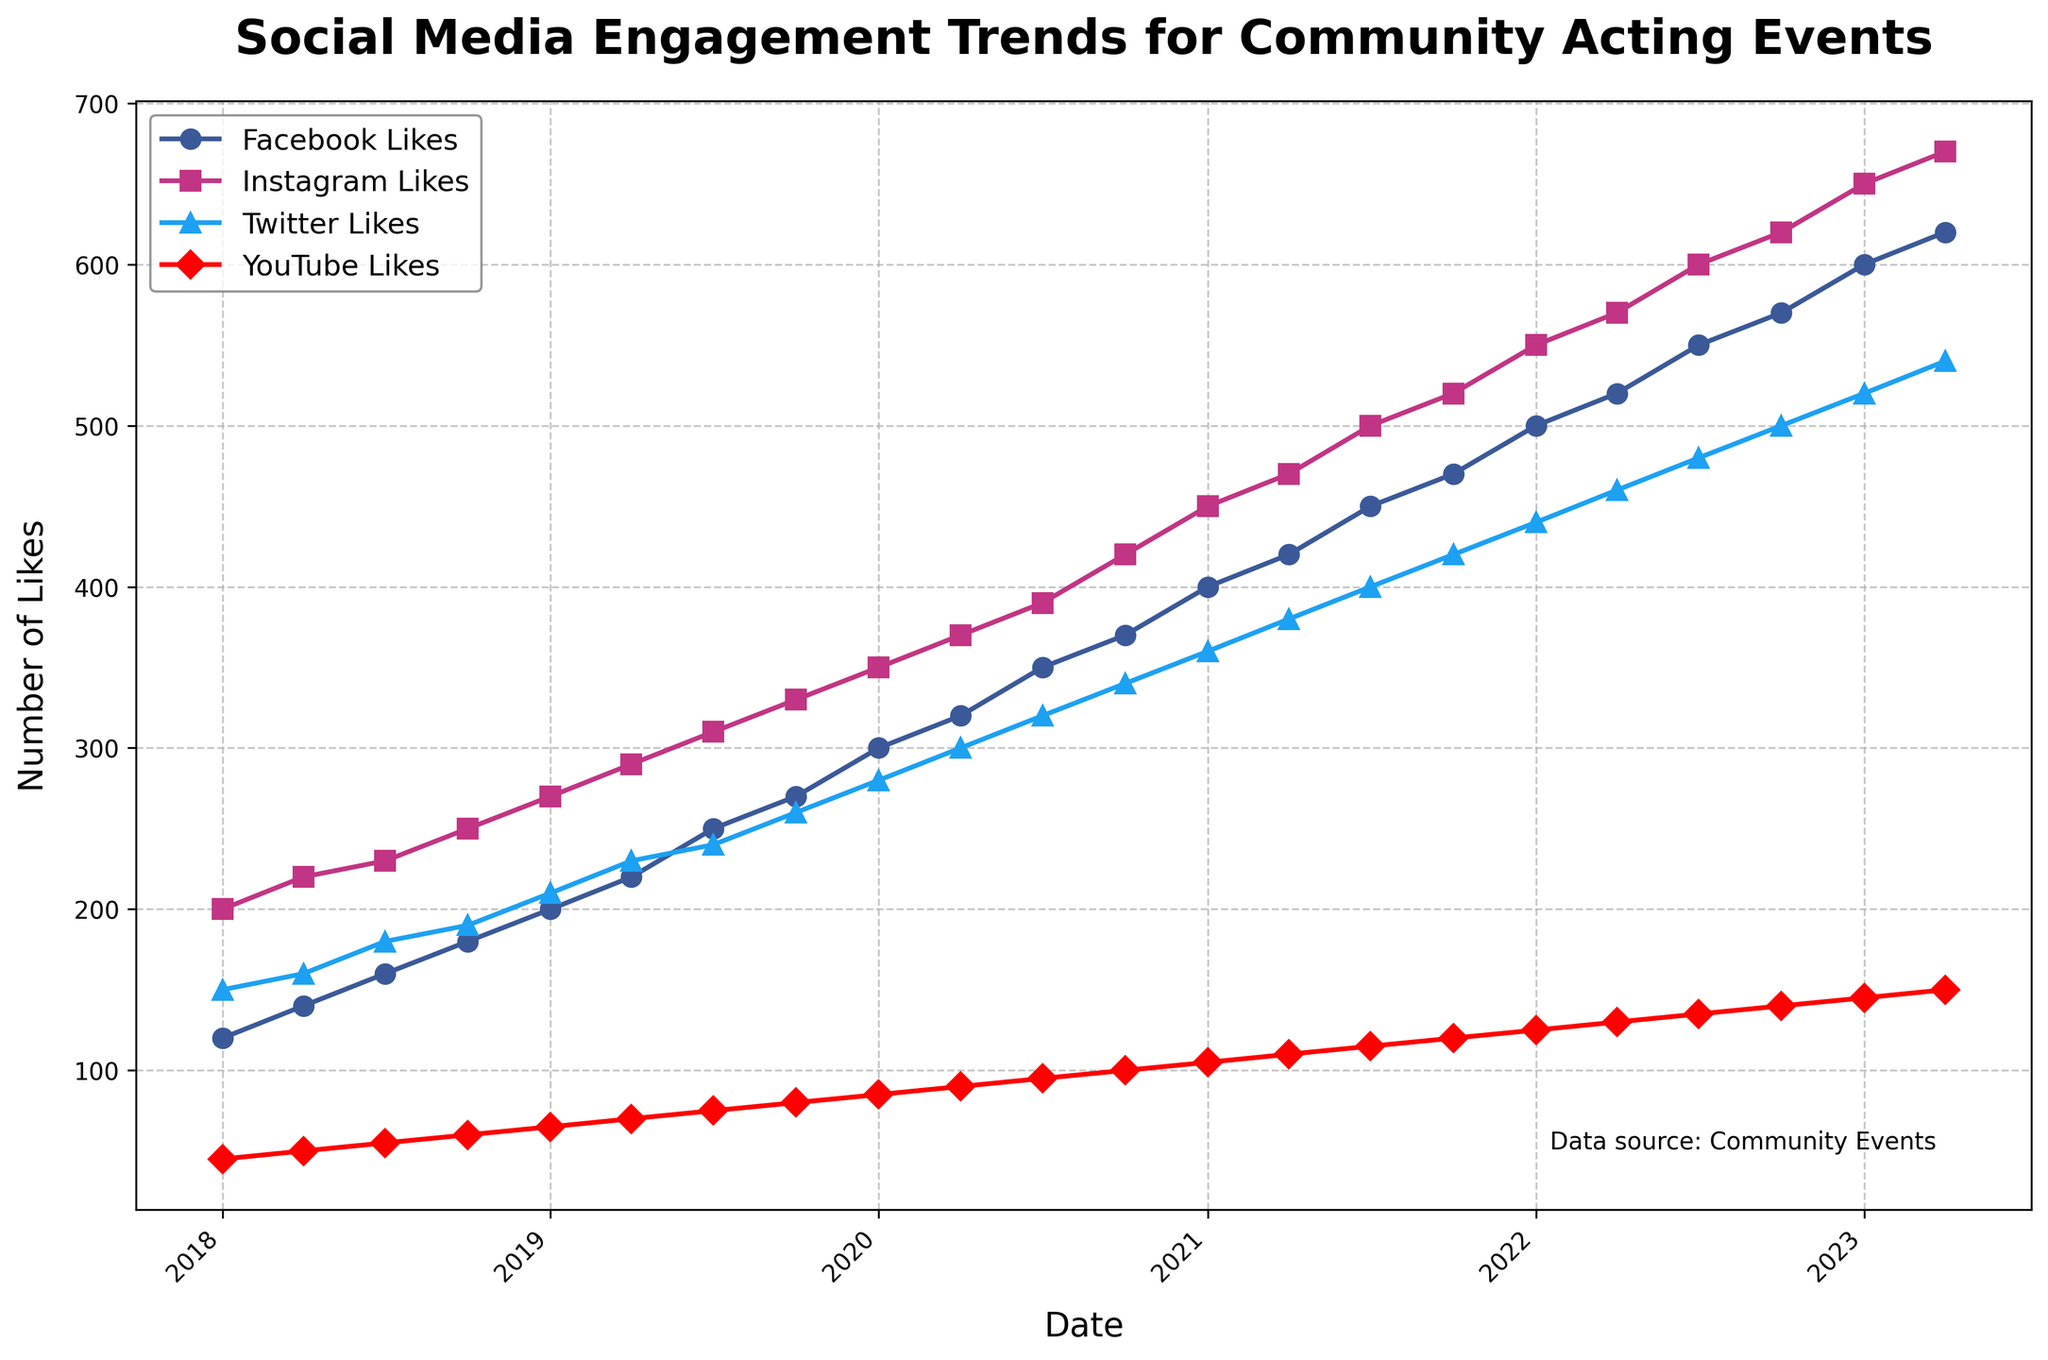What are the platforms being compared in the plot? The platforms are identified by distinct colors and markers. From the legend, we see that the platforms compared are Facebook, Instagram, Twitter, and YouTube.
Answer: Facebook, Instagram, Twitter, YouTube How many years of data are represented in the plot? The x-axis shows dates from 2018 to 2023, which can be deduced to span five years.
Answer: Five Which platform shows the most significant increase in likes over the period? Observing the trends, YouTube Likes increases from 500 in 2018 to 1550 in 2023, which is a significant rise compared to other platforms.
Answer: YouTube What is the general trend for Instagram Likes over the five years? The plot shows a consistent upward trend for Instagram Likes, starting at 200 in 2018 and reaching 670 in 2023.
Answer: Upward At which point did Facebook Likes first surpass 300? The plateau of Facebook Likes first goes above 300 between 2019 and 2020, precisely at the mark of January 2020.
Answer: January 2020 Which platform had the smallest growth in likes from 2018 to 2023? By comparing the initial and final data points for each platform, we find Twitter Likes grew from 150 to 540, which is the smallest growth of 390 likes.
Answer: Twitter How do Likes for Facebook and Instagram compare at the beginning of 2021? Drawing vertical lines from January 2021, Facebook has around 400 Likes, while Instagram has about 450 Likes.
Answer: Facebook: 400, Instagram: 450 In which year did YouTube Likes exceed 1000 for the first time? The trend shows YouTube Likes surpassing 1000 in the mid of 2020.
Answer: 2020 What is the average number of total likes for Facebook per year from 2018 to 2023? Collect the Facebook Likes data for each year, sum (120+140+160+180+200+220+250+270+300+320+350+370+400+420+450+470+500+520+550+570+600+620), divide by the number of data points (22): Total = 7850, Average = 357.
Answer: 357 